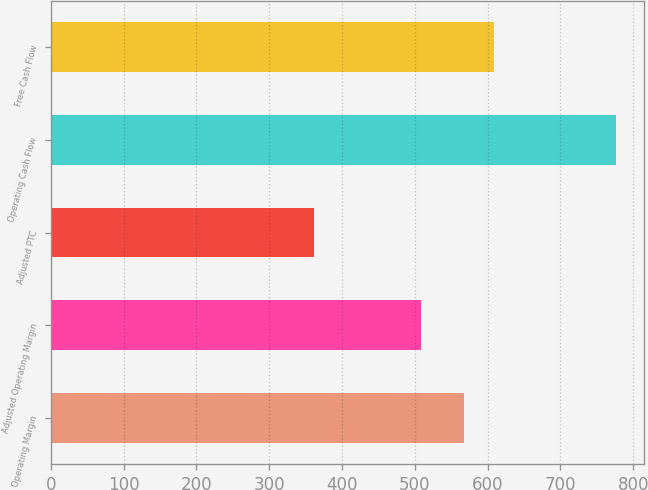Convert chart. <chart><loc_0><loc_0><loc_500><loc_500><bar_chart><fcel>Operating Margin<fcel>Adjusted Operating Margin<fcel>Adjusted PTC<fcel>Operating Cash Flow<fcel>Free Cash Flow<nl><fcel>567<fcel>509<fcel>361<fcel>776<fcel>608.5<nl></chart> 